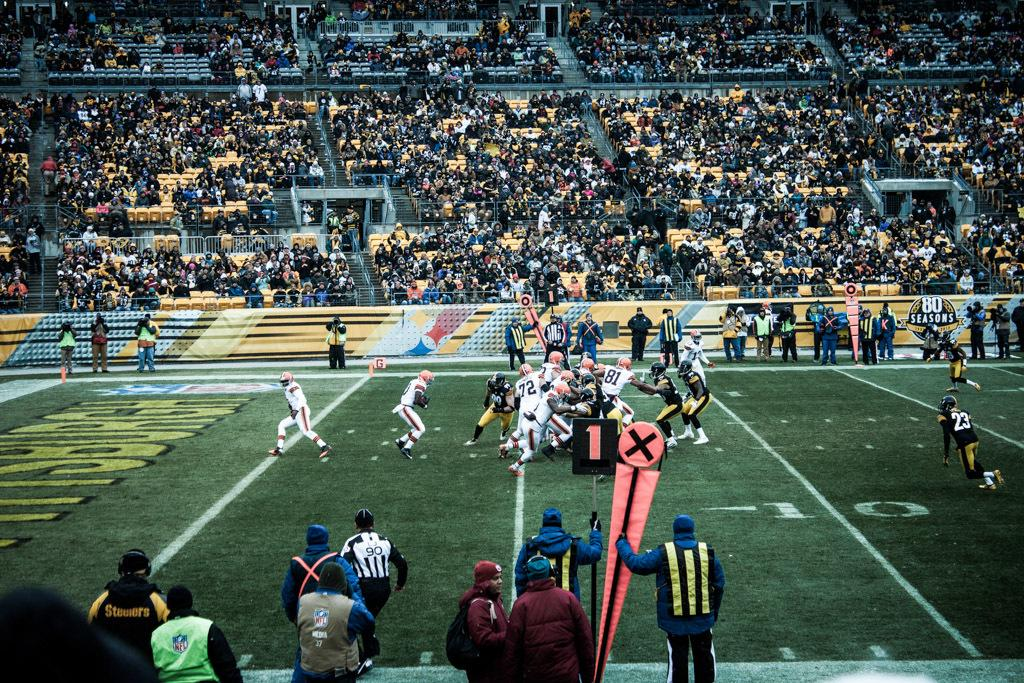<image>
Present a compact description of the photo's key features. A football game being played in a crowded stadium with action near the 10 yard line. 